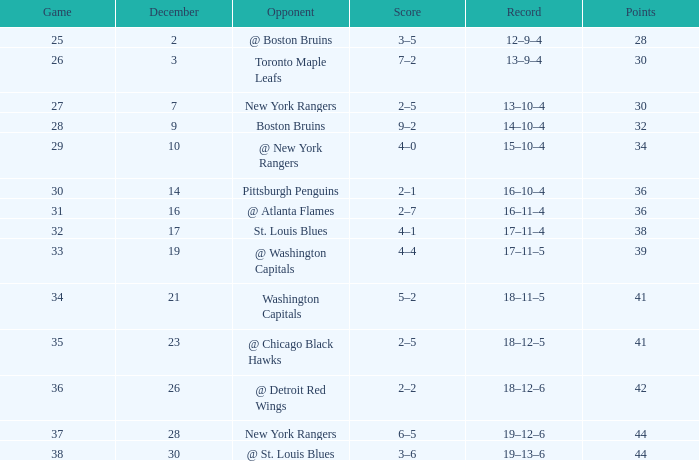Which Score has Points of 36, and a Game of 30? 2–1. 